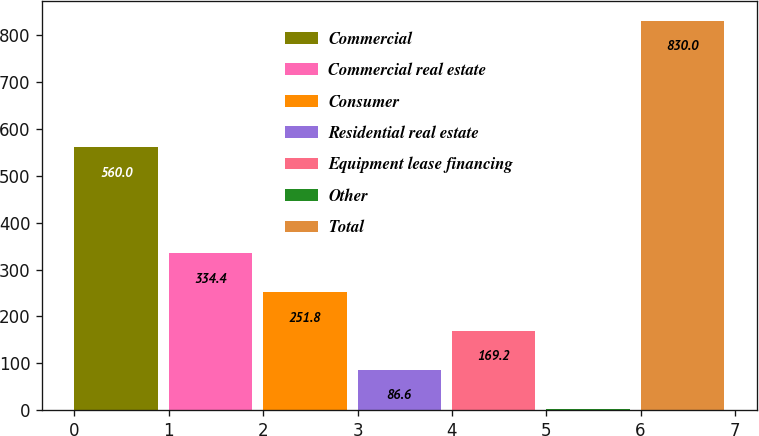Convert chart. <chart><loc_0><loc_0><loc_500><loc_500><bar_chart><fcel>Commercial<fcel>Commercial real estate<fcel>Consumer<fcel>Residential real estate<fcel>Equipment lease financing<fcel>Other<fcel>Total<nl><fcel>560<fcel>334.4<fcel>251.8<fcel>86.6<fcel>169.2<fcel>4<fcel>830<nl></chart> 